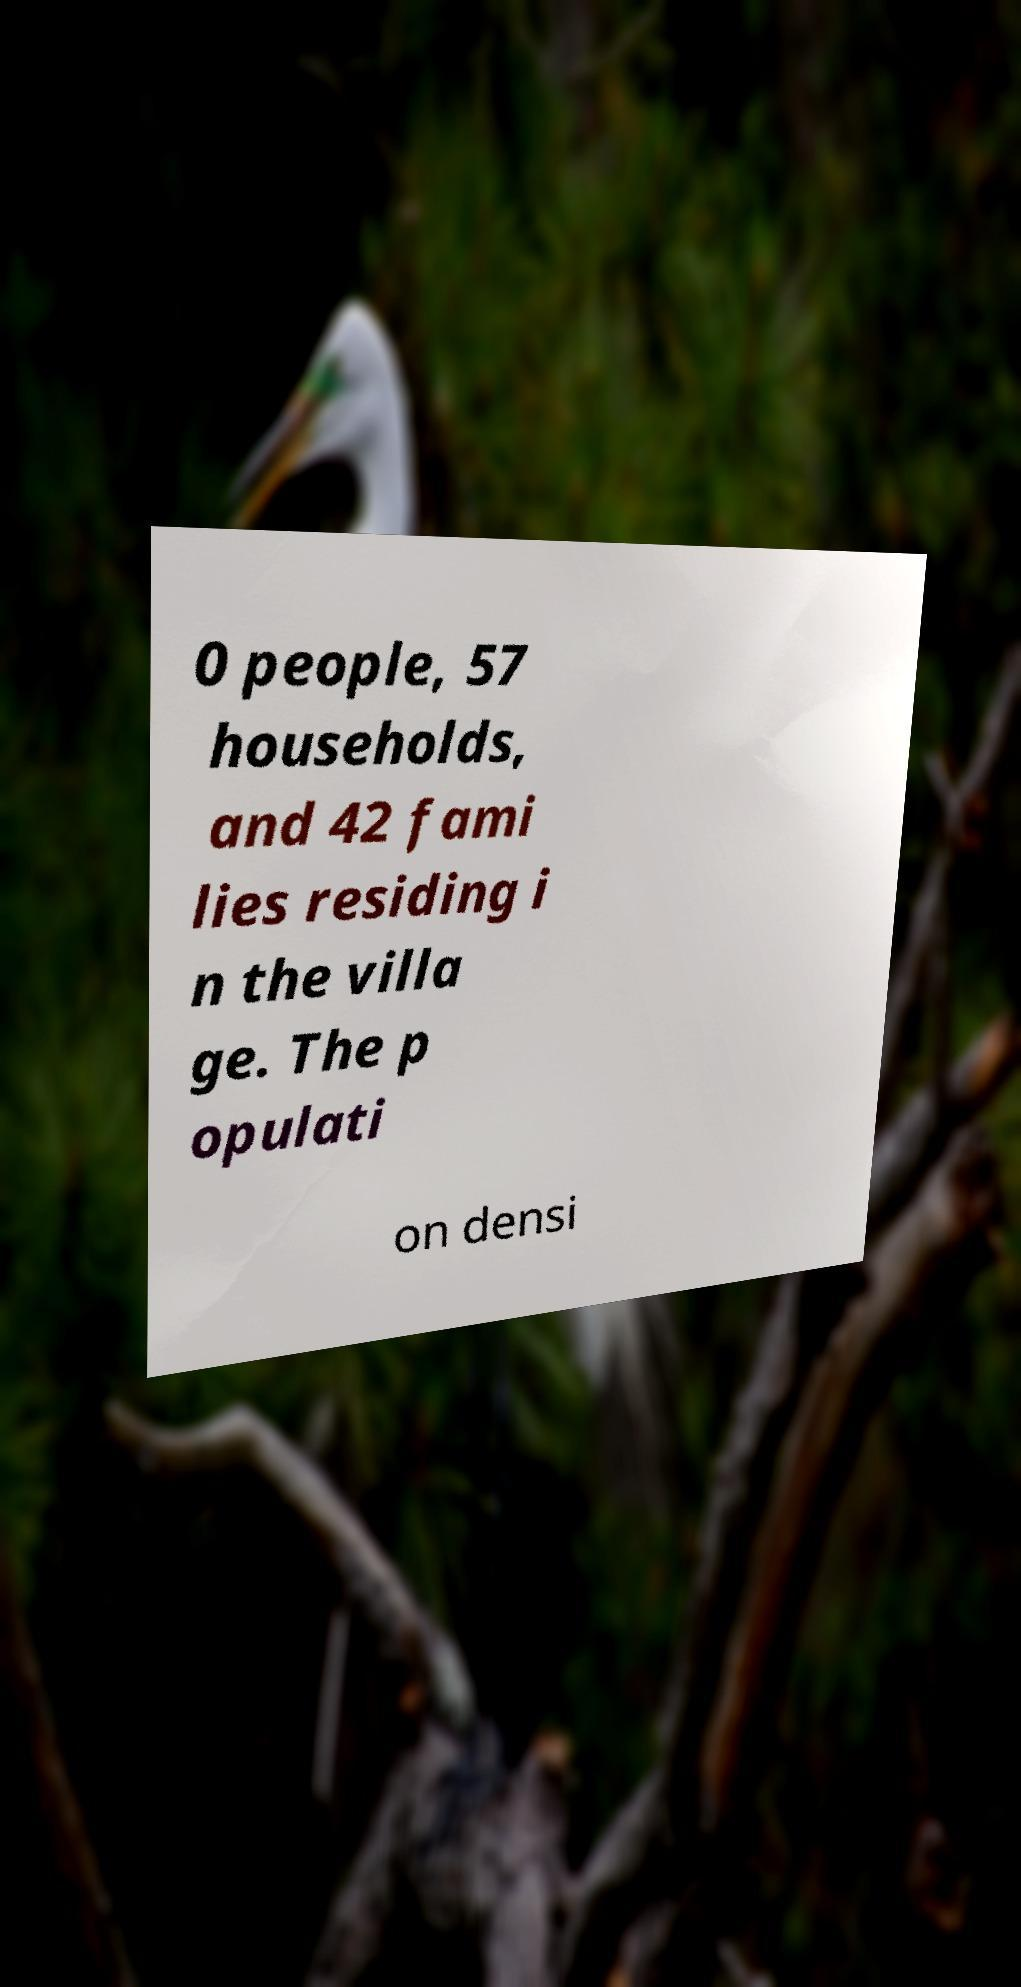Could you assist in decoding the text presented in this image and type it out clearly? 0 people, 57 households, and 42 fami lies residing i n the villa ge. The p opulati on densi 